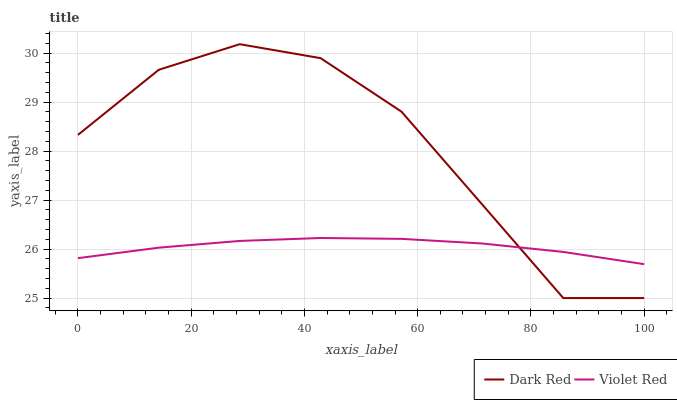Does Violet Red have the minimum area under the curve?
Answer yes or no. Yes. Does Dark Red have the maximum area under the curve?
Answer yes or no. Yes. Does Violet Red have the maximum area under the curve?
Answer yes or no. No. Is Violet Red the smoothest?
Answer yes or no. Yes. Is Dark Red the roughest?
Answer yes or no. Yes. Is Violet Red the roughest?
Answer yes or no. No. Does Dark Red have the lowest value?
Answer yes or no. Yes. Does Violet Red have the lowest value?
Answer yes or no. No. Does Dark Red have the highest value?
Answer yes or no. Yes. Does Violet Red have the highest value?
Answer yes or no. No. Does Dark Red intersect Violet Red?
Answer yes or no. Yes. Is Dark Red less than Violet Red?
Answer yes or no. No. Is Dark Red greater than Violet Red?
Answer yes or no. No. 